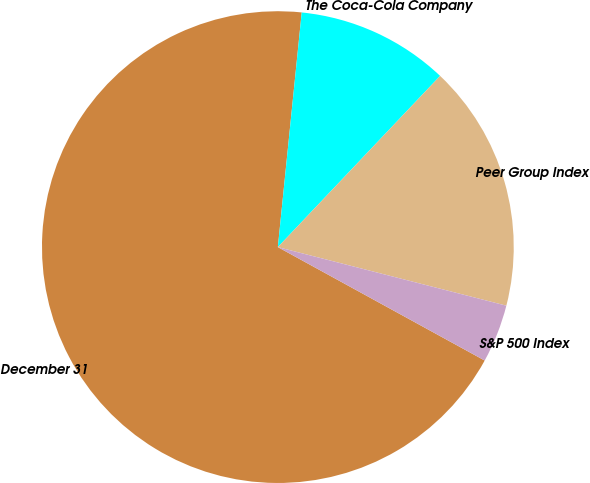<chart> <loc_0><loc_0><loc_500><loc_500><pie_chart><fcel>December 31<fcel>The Coca-Cola Company<fcel>Peer Group Index<fcel>S&P 500 Index<nl><fcel>68.63%<fcel>10.46%<fcel>16.92%<fcel>3.99%<nl></chart> 